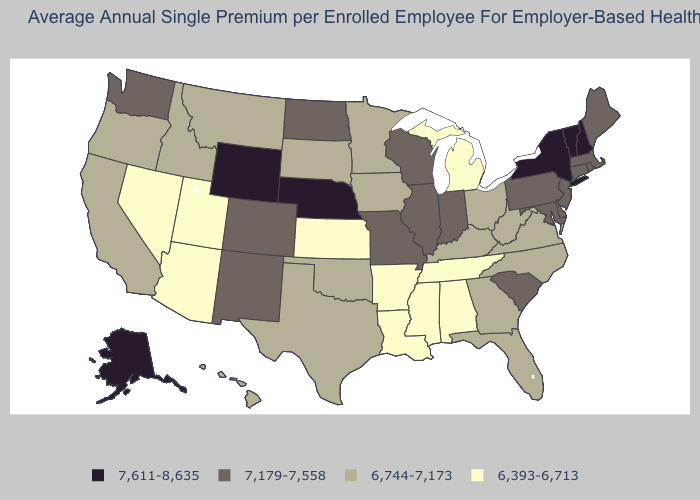Among the states that border Minnesota , which have the highest value?
Give a very brief answer. North Dakota, Wisconsin. Which states have the lowest value in the USA?
Give a very brief answer. Alabama, Arizona, Arkansas, Kansas, Louisiana, Michigan, Mississippi, Nevada, Tennessee, Utah. What is the value of South Carolina?
Quick response, please. 7,179-7,558. Name the states that have a value in the range 6,744-7,173?
Give a very brief answer. California, Florida, Georgia, Hawaii, Idaho, Iowa, Kentucky, Minnesota, Montana, North Carolina, Ohio, Oklahoma, Oregon, South Dakota, Texas, Virginia, West Virginia. Name the states that have a value in the range 7,611-8,635?
Write a very short answer. Alaska, Nebraska, New Hampshire, New York, Vermont, Wyoming. What is the value of Minnesota?
Answer briefly. 6,744-7,173. Among the states that border New Jersey , does New York have the lowest value?
Keep it brief. No. Does Wyoming have a higher value than California?
Give a very brief answer. Yes. Name the states that have a value in the range 6,744-7,173?
Write a very short answer. California, Florida, Georgia, Hawaii, Idaho, Iowa, Kentucky, Minnesota, Montana, North Carolina, Ohio, Oklahoma, Oregon, South Dakota, Texas, Virginia, West Virginia. Does Maryland have the highest value in the South?
Concise answer only. Yes. What is the value of Kentucky?
Short answer required. 6,744-7,173. Name the states that have a value in the range 6,393-6,713?
Keep it brief. Alabama, Arizona, Arkansas, Kansas, Louisiana, Michigan, Mississippi, Nevada, Tennessee, Utah. Which states have the lowest value in the Northeast?
Keep it brief. Connecticut, Maine, Massachusetts, New Jersey, Pennsylvania, Rhode Island. Name the states that have a value in the range 6,744-7,173?
Short answer required. California, Florida, Georgia, Hawaii, Idaho, Iowa, Kentucky, Minnesota, Montana, North Carolina, Ohio, Oklahoma, Oregon, South Dakota, Texas, Virginia, West Virginia. Does Arizona have a lower value than New Mexico?
Short answer required. Yes. 